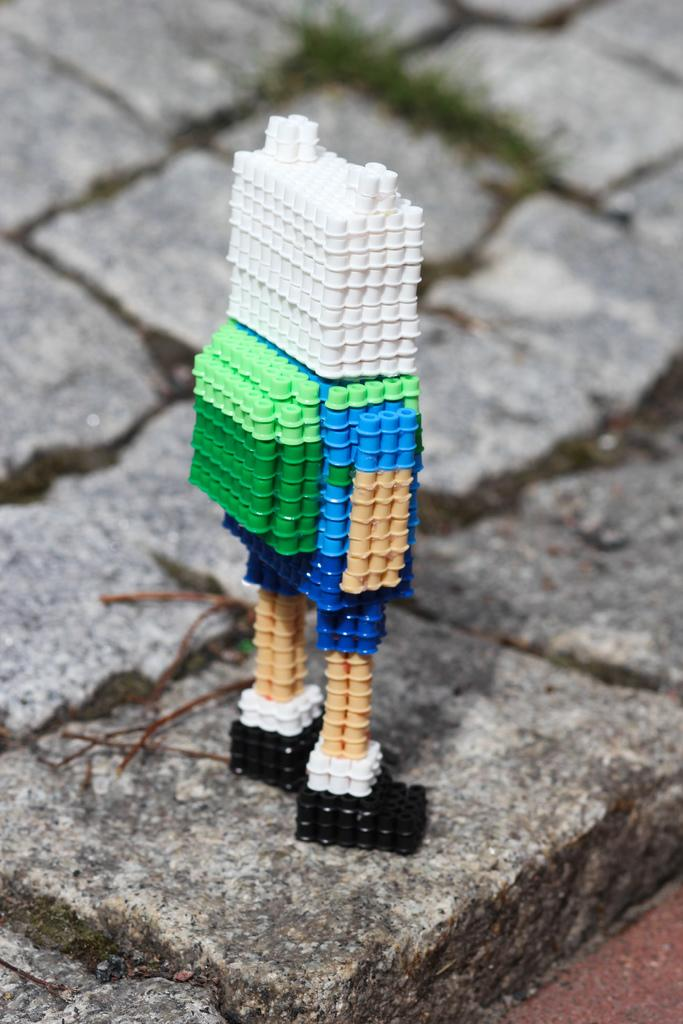What type of toy is present in the image? There is a toy in the shape of a human in the image. What is the toy placed on? The toy is on a stone floor. How many houses are depicted in the image? There are no houses present in the image; it features a toy on a stone floor. What type of button is being pushed by the toy in the image? There is no button present in the image; it only features a toy on a stone floor. 